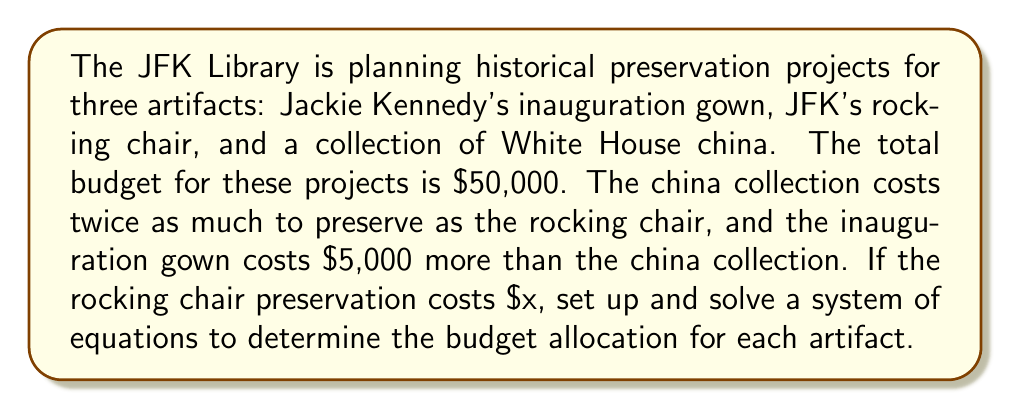Teach me how to tackle this problem. Let's define our variables:
$x$ = cost to preserve JFK's rocking chair
$2x$ = cost to preserve the White House china collection
$2x + 5000$ = cost to preserve Jackie Kennedy's inauguration gown

Step 1: Set up the system of equations
$$\begin{cases}
x + 2x + (2x + 5000) = 50000 \\
x + 2x + 2x + 5000 = 50000
\end{cases}$$

Step 2: Simplify the equation
$$5x + 5000 = 50000$$

Step 3: Solve for $x$
$$\begin{align}
5x &= 45000 \\
x &= 9000
\end{align}$$

Step 4: Calculate the cost for each artifact
Rocking chair: $x = 9000$
White House china: $2x = 2(9000) = 18000$
Inauguration gown: $2x + 5000 = 2(9000) + 5000 = 23000$

Step 5: Verify the total
$$9000 + 18000 + 23000 = 50000$$

The budget allocation is correct as it adds up to the total budget of $50,000.
Answer: Rocking chair: $9,000, China collection: $18,000, Inauguration gown: $23,000 